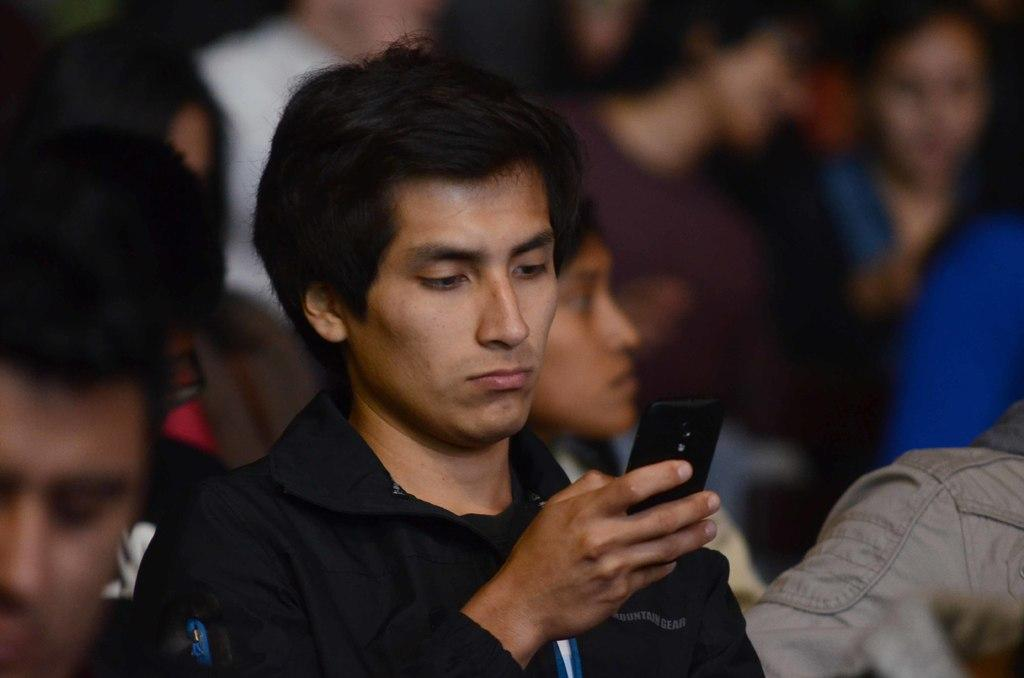What is the main subject of the image? There is a person in the image. What is the person doing in the image? The person is staring at a mobile phone. How is the person holding the mobile phone? The person is holding the mobile phone in their right hand. Can you describe the background of the image? There are people in the background of the image. What type of caption can be seen on the lake in the image? There is no lake or caption present in the image; it features a person holding a mobile phone. How many pins are visible on the person's shirt in the image? There is no mention of pins or a shirt in the provided facts, so it cannot be determined from the image. 